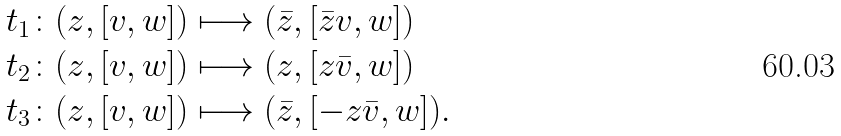Convert formula to latex. <formula><loc_0><loc_0><loc_500><loc_500>t _ { 1 } \colon ( z , [ v , w ] ) & \longmapsto ( \bar { z } , [ \bar { z } v , w ] ) \\ t _ { 2 } \colon ( z , [ v , w ] ) & \longmapsto ( z , [ z \bar { v } , w ] ) \\ t _ { 3 } \colon ( z , [ v , w ] ) & \longmapsto ( \bar { z } , [ - z \bar { v } , w ] ) .</formula> 